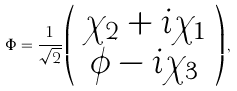Convert formula to latex. <formula><loc_0><loc_0><loc_500><loc_500>\Phi = \frac { 1 } { \sqrt { 2 } } \left ( \begin{array} { c } { { \chi _ { 2 } + i \chi _ { 1 } } } \\ { { \phi - i \chi _ { 3 } } } \end{array} \right ) ,</formula> 